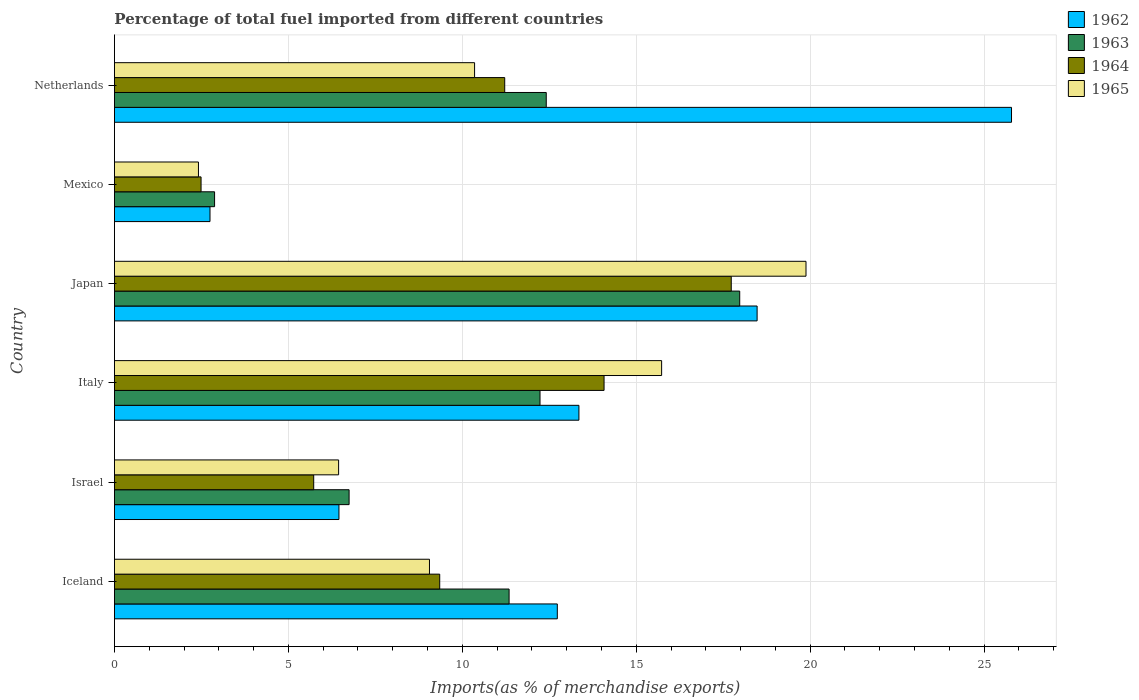How many different coloured bars are there?
Your answer should be very brief. 4. How many groups of bars are there?
Your response must be concise. 6. Are the number of bars per tick equal to the number of legend labels?
Provide a succinct answer. Yes. How many bars are there on the 1st tick from the top?
Offer a very short reply. 4. How many bars are there on the 6th tick from the bottom?
Ensure brevity in your answer.  4. What is the label of the 4th group of bars from the top?
Provide a succinct answer. Italy. In how many cases, is the number of bars for a given country not equal to the number of legend labels?
Provide a short and direct response. 0. What is the percentage of imports to different countries in 1964 in Japan?
Provide a short and direct response. 17.73. Across all countries, what is the maximum percentage of imports to different countries in 1964?
Make the answer very short. 17.73. Across all countries, what is the minimum percentage of imports to different countries in 1963?
Your answer should be compact. 2.88. In which country was the percentage of imports to different countries in 1964 minimum?
Give a very brief answer. Mexico. What is the total percentage of imports to different countries in 1965 in the graph?
Your response must be concise. 63.88. What is the difference between the percentage of imports to different countries in 1964 in Israel and that in Japan?
Offer a terse response. -12. What is the difference between the percentage of imports to different countries in 1962 in Japan and the percentage of imports to different countries in 1963 in Italy?
Provide a short and direct response. 6.24. What is the average percentage of imports to different countries in 1964 per country?
Make the answer very short. 10.1. What is the difference between the percentage of imports to different countries in 1963 and percentage of imports to different countries in 1965 in Iceland?
Offer a very short reply. 2.29. What is the ratio of the percentage of imports to different countries in 1965 in Israel to that in Italy?
Offer a very short reply. 0.41. Is the percentage of imports to different countries in 1962 in Italy less than that in Mexico?
Your response must be concise. No. What is the difference between the highest and the second highest percentage of imports to different countries in 1965?
Offer a very short reply. 4.15. What is the difference between the highest and the lowest percentage of imports to different countries in 1964?
Your answer should be compact. 15.24. Is it the case that in every country, the sum of the percentage of imports to different countries in 1962 and percentage of imports to different countries in 1963 is greater than the sum of percentage of imports to different countries in 1965 and percentage of imports to different countries in 1964?
Ensure brevity in your answer.  No. What does the 1st bar from the top in Mexico represents?
Your response must be concise. 1965. What does the 4th bar from the bottom in Iceland represents?
Offer a terse response. 1965. How many bars are there?
Provide a succinct answer. 24. Are all the bars in the graph horizontal?
Your response must be concise. Yes. What is the difference between two consecutive major ticks on the X-axis?
Provide a succinct answer. 5. How many legend labels are there?
Make the answer very short. 4. What is the title of the graph?
Keep it short and to the point. Percentage of total fuel imported from different countries. What is the label or title of the X-axis?
Offer a very short reply. Imports(as % of merchandise exports). What is the Imports(as % of merchandise exports) of 1962 in Iceland?
Provide a short and direct response. 12.73. What is the Imports(as % of merchandise exports) in 1963 in Iceland?
Provide a succinct answer. 11.35. What is the Imports(as % of merchandise exports) of 1964 in Iceland?
Make the answer very short. 9.35. What is the Imports(as % of merchandise exports) in 1965 in Iceland?
Ensure brevity in your answer.  9.06. What is the Imports(as % of merchandise exports) of 1962 in Israel?
Your answer should be compact. 6.45. What is the Imports(as % of merchandise exports) of 1963 in Israel?
Ensure brevity in your answer.  6.75. What is the Imports(as % of merchandise exports) in 1964 in Israel?
Offer a very short reply. 5.73. What is the Imports(as % of merchandise exports) in 1965 in Israel?
Ensure brevity in your answer.  6.44. What is the Imports(as % of merchandise exports) in 1962 in Italy?
Keep it short and to the point. 13.35. What is the Imports(as % of merchandise exports) of 1963 in Italy?
Provide a short and direct response. 12.23. What is the Imports(as % of merchandise exports) of 1964 in Italy?
Give a very brief answer. 14.07. What is the Imports(as % of merchandise exports) in 1965 in Italy?
Offer a very short reply. 15.73. What is the Imports(as % of merchandise exports) of 1962 in Japan?
Make the answer very short. 18.47. What is the Imports(as % of merchandise exports) of 1963 in Japan?
Give a very brief answer. 17.97. What is the Imports(as % of merchandise exports) of 1964 in Japan?
Your answer should be very brief. 17.73. What is the Imports(as % of merchandise exports) in 1965 in Japan?
Your response must be concise. 19.88. What is the Imports(as % of merchandise exports) of 1962 in Mexico?
Your answer should be very brief. 2.75. What is the Imports(as % of merchandise exports) of 1963 in Mexico?
Your answer should be very brief. 2.88. What is the Imports(as % of merchandise exports) in 1964 in Mexico?
Your response must be concise. 2.49. What is the Imports(as % of merchandise exports) of 1965 in Mexico?
Your answer should be compact. 2.42. What is the Imports(as % of merchandise exports) in 1962 in Netherlands?
Provide a succinct answer. 25.79. What is the Imports(as % of merchandise exports) of 1963 in Netherlands?
Provide a succinct answer. 12.41. What is the Imports(as % of merchandise exports) in 1964 in Netherlands?
Give a very brief answer. 11.22. What is the Imports(as % of merchandise exports) in 1965 in Netherlands?
Ensure brevity in your answer.  10.35. Across all countries, what is the maximum Imports(as % of merchandise exports) in 1962?
Keep it short and to the point. 25.79. Across all countries, what is the maximum Imports(as % of merchandise exports) of 1963?
Keep it short and to the point. 17.97. Across all countries, what is the maximum Imports(as % of merchandise exports) in 1964?
Your answer should be very brief. 17.73. Across all countries, what is the maximum Imports(as % of merchandise exports) in 1965?
Your answer should be compact. 19.88. Across all countries, what is the minimum Imports(as % of merchandise exports) of 1962?
Keep it short and to the point. 2.75. Across all countries, what is the minimum Imports(as % of merchandise exports) of 1963?
Your answer should be very brief. 2.88. Across all countries, what is the minimum Imports(as % of merchandise exports) of 1964?
Offer a terse response. 2.49. Across all countries, what is the minimum Imports(as % of merchandise exports) of 1965?
Offer a very short reply. 2.42. What is the total Imports(as % of merchandise exports) of 1962 in the graph?
Your answer should be very brief. 79.55. What is the total Imports(as % of merchandise exports) in 1963 in the graph?
Your response must be concise. 63.59. What is the total Imports(as % of merchandise exports) of 1964 in the graph?
Your answer should be very brief. 60.59. What is the total Imports(as % of merchandise exports) in 1965 in the graph?
Offer a terse response. 63.88. What is the difference between the Imports(as % of merchandise exports) in 1962 in Iceland and that in Israel?
Provide a short and direct response. 6.28. What is the difference between the Imports(as % of merchandise exports) in 1963 in Iceland and that in Israel?
Give a very brief answer. 4.6. What is the difference between the Imports(as % of merchandise exports) of 1964 in Iceland and that in Israel?
Keep it short and to the point. 3.62. What is the difference between the Imports(as % of merchandise exports) of 1965 in Iceland and that in Israel?
Your answer should be very brief. 2.61. What is the difference between the Imports(as % of merchandise exports) of 1962 in Iceland and that in Italy?
Ensure brevity in your answer.  -0.62. What is the difference between the Imports(as % of merchandise exports) in 1963 in Iceland and that in Italy?
Your answer should be very brief. -0.89. What is the difference between the Imports(as % of merchandise exports) in 1964 in Iceland and that in Italy?
Your response must be concise. -4.72. What is the difference between the Imports(as % of merchandise exports) in 1965 in Iceland and that in Italy?
Ensure brevity in your answer.  -6.67. What is the difference between the Imports(as % of merchandise exports) in 1962 in Iceland and that in Japan?
Your answer should be compact. -5.74. What is the difference between the Imports(as % of merchandise exports) in 1963 in Iceland and that in Japan?
Keep it short and to the point. -6.63. What is the difference between the Imports(as % of merchandise exports) in 1964 in Iceland and that in Japan?
Make the answer very short. -8.38. What is the difference between the Imports(as % of merchandise exports) of 1965 in Iceland and that in Japan?
Keep it short and to the point. -10.82. What is the difference between the Imports(as % of merchandise exports) of 1962 in Iceland and that in Mexico?
Give a very brief answer. 9.98. What is the difference between the Imports(as % of merchandise exports) in 1963 in Iceland and that in Mexico?
Offer a terse response. 8.47. What is the difference between the Imports(as % of merchandise exports) of 1964 in Iceland and that in Mexico?
Ensure brevity in your answer.  6.86. What is the difference between the Imports(as % of merchandise exports) of 1965 in Iceland and that in Mexico?
Your answer should be compact. 6.64. What is the difference between the Imports(as % of merchandise exports) of 1962 in Iceland and that in Netherlands?
Your answer should be compact. -13.06. What is the difference between the Imports(as % of merchandise exports) of 1963 in Iceland and that in Netherlands?
Offer a very short reply. -1.07. What is the difference between the Imports(as % of merchandise exports) of 1964 in Iceland and that in Netherlands?
Offer a very short reply. -1.87. What is the difference between the Imports(as % of merchandise exports) in 1965 in Iceland and that in Netherlands?
Your response must be concise. -1.3. What is the difference between the Imports(as % of merchandise exports) in 1962 in Israel and that in Italy?
Keep it short and to the point. -6.9. What is the difference between the Imports(as % of merchandise exports) in 1963 in Israel and that in Italy?
Your answer should be very brief. -5.49. What is the difference between the Imports(as % of merchandise exports) in 1964 in Israel and that in Italy?
Your answer should be compact. -8.35. What is the difference between the Imports(as % of merchandise exports) in 1965 in Israel and that in Italy?
Your answer should be very brief. -9.29. What is the difference between the Imports(as % of merchandise exports) in 1962 in Israel and that in Japan?
Keep it short and to the point. -12.02. What is the difference between the Imports(as % of merchandise exports) of 1963 in Israel and that in Japan?
Provide a short and direct response. -11.23. What is the difference between the Imports(as % of merchandise exports) of 1964 in Israel and that in Japan?
Ensure brevity in your answer.  -12. What is the difference between the Imports(as % of merchandise exports) of 1965 in Israel and that in Japan?
Provide a short and direct response. -13.44. What is the difference between the Imports(as % of merchandise exports) in 1962 in Israel and that in Mexico?
Give a very brief answer. 3.71. What is the difference between the Imports(as % of merchandise exports) of 1963 in Israel and that in Mexico?
Provide a short and direct response. 3.87. What is the difference between the Imports(as % of merchandise exports) of 1964 in Israel and that in Mexico?
Your answer should be compact. 3.24. What is the difference between the Imports(as % of merchandise exports) in 1965 in Israel and that in Mexico?
Your answer should be compact. 4.03. What is the difference between the Imports(as % of merchandise exports) of 1962 in Israel and that in Netherlands?
Make the answer very short. -19.33. What is the difference between the Imports(as % of merchandise exports) of 1963 in Israel and that in Netherlands?
Your answer should be very brief. -5.67. What is the difference between the Imports(as % of merchandise exports) of 1964 in Israel and that in Netherlands?
Your response must be concise. -5.49. What is the difference between the Imports(as % of merchandise exports) of 1965 in Israel and that in Netherlands?
Provide a succinct answer. -3.91. What is the difference between the Imports(as % of merchandise exports) of 1962 in Italy and that in Japan?
Give a very brief answer. -5.12. What is the difference between the Imports(as % of merchandise exports) of 1963 in Italy and that in Japan?
Keep it short and to the point. -5.74. What is the difference between the Imports(as % of merchandise exports) of 1964 in Italy and that in Japan?
Provide a succinct answer. -3.66. What is the difference between the Imports(as % of merchandise exports) of 1965 in Italy and that in Japan?
Provide a short and direct response. -4.15. What is the difference between the Imports(as % of merchandise exports) of 1962 in Italy and that in Mexico?
Your answer should be compact. 10.61. What is the difference between the Imports(as % of merchandise exports) of 1963 in Italy and that in Mexico?
Your answer should be compact. 9.36. What is the difference between the Imports(as % of merchandise exports) of 1964 in Italy and that in Mexico?
Make the answer very short. 11.58. What is the difference between the Imports(as % of merchandise exports) in 1965 in Italy and that in Mexico?
Make the answer very short. 13.31. What is the difference between the Imports(as % of merchandise exports) of 1962 in Italy and that in Netherlands?
Provide a succinct answer. -12.44. What is the difference between the Imports(as % of merchandise exports) of 1963 in Italy and that in Netherlands?
Keep it short and to the point. -0.18. What is the difference between the Imports(as % of merchandise exports) in 1964 in Italy and that in Netherlands?
Your response must be concise. 2.86. What is the difference between the Imports(as % of merchandise exports) of 1965 in Italy and that in Netherlands?
Your answer should be compact. 5.38. What is the difference between the Imports(as % of merchandise exports) in 1962 in Japan and that in Mexico?
Offer a terse response. 15.73. What is the difference between the Imports(as % of merchandise exports) in 1963 in Japan and that in Mexico?
Your response must be concise. 15.1. What is the difference between the Imports(as % of merchandise exports) in 1964 in Japan and that in Mexico?
Offer a very short reply. 15.24. What is the difference between the Imports(as % of merchandise exports) of 1965 in Japan and that in Mexico?
Provide a short and direct response. 17.46. What is the difference between the Imports(as % of merchandise exports) of 1962 in Japan and that in Netherlands?
Offer a very short reply. -7.31. What is the difference between the Imports(as % of merchandise exports) of 1963 in Japan and that in Netherlands?
Your response must be concise. 5.56. What is the difference between the Imports(as % of merchandise exports) in 1964 in Japan and that in Netherlands?
Your answer should be compact. 6.51. What is the difference between the Imports(as % of merchandise exports) in 1965 in Japan and that in Netherlands?
Offer a terse response. 9.53. What is the difference between the Imports(as % of merchandise exports) of 1962 in Mexico and that in Netherlands?
Your answer should be compact. -23.04. What is the difference between the Imports(as % of merchandise exports) in 1963 in Mexico and that in Netherlands?
Your answer should be very brief. -9.53. What is the difference between the Imports(as % of merchandise exports) in 1964 in Mexico and that in Netherlands?
Provide a short and direct response. -8.73. What is the difference between the Imports(as % of merchandise exports) of 1965 in Mexico and that in Netherlands?
Give a very brief answer. -7.94. What is the difference between the Imports(as % of merchandise exports) of 1962 in Iceland and the Imports(as % of merchandise exports) of 1963 in Israel?
Ensure brevity in your answer.  5.99. What is the difference between the Imports(as % of merchandise exports) in 1962 in Iceland and the Imports(as % of merchandise exports) in 1964 in Israel?
Make the answer very short. 7. What is the difference between the Imports(as % of merchandise exports) of 1962 in Iceland and the Imports(as % of merchandise exports) of 1965 in Israel?
Your response must be concise. 6.29. What is the difference between the Imports(as % of merchandise exports) in 1963 in Iceland and the Imports(as % of merchandise exports) in 1964 in Israel?
Give a very brief answer. 5.62. What is the difference between the Imports(as % of merchandise exports) of 1963 in Iceland and the Imports(as % of merchandise exports) of 1965 in Israel?
Your response must be concise. 4.9. What is the difference between the Imports(as % of merchandise exports) in 1964 in Iceland and the Imports(as % of merchandise exports) in 1965 in Israel?
Your answer should be very brief. 2.91. What is the difference between the Imports(as % of merchandise exports) of 1962 in Iceland and the Imports(as % of merchandise exports) of 1963 in Italy?
Provide a short and direct response. 0.5. What is the difference between the Imports(as % of merchandise exports) of 1962 in Iceland and the Imports(as % of merchandise exports) of 1964 in Italy?
Make the answer very short. -1.34. What is the difference between the Imports(as % of merchandise exports) in 1962 in Iceland and the Imports(as % of merchandise exports) in 1965 in Italy?
Make the answer very short. -3. What is the difference between the Imports(as % of merchandise exports) in 1963 in Iceland and the Imports(as % of merchandise exports) in 1964 in Italy?
Give a very brief answer. -2.73. What is the difference between the Imports(as % of merchandise exports) in 1963 in Iceland and the Imports(as % of merchandise exports) in 1965 in Italy?
Keep it short and to the point. -4.38. What is the difference between the Imports(as % of merchandise exports) of 1964 in Iceland and the Imports(as % of merchandise exports) of 1965 in Italy?
Make the answer very short. -6.38. What is the difference between the Imports(as % of merchandise exports) of 1962 in Iceland and the Imports(as % of merchandise exports) of 1963 in Japan?
Ensure brevity in your answer.  -5.24. What is the difference between the Imports(as % of merchandise exports) of 1962 in Iceland and the Imports(as % of merchandise exports) of 1964 in Japan?
Provide a succinct answer. -5. What is the difference between the Imports(as % of merchandise exports) in 1962 in Iceland and the Imports(as % of merchandise exports) in 1965 in Japan?
Your answer should be very brief. -7.15. What is the difference between the Imports(as % of merchandise exports) of 1963 in Iceland and the Imports(as % of merchandise exports) of 1964 in Japan?
Your response must be concise. -6.39. What is the difference between the Imports(as % of merchandise exports) of 1963 in Iceland and the Imports(as % of merchandise exports) of 1965 in Japan?
Offer a terse response. -8.53. What is the difference between the Imports(as % of merchandise exports) in 1964 in Iceland and the Imports(as % of merchandise exports) in 1965 in Japan?
Your answer should be very brief. -10.53. What is the difference between the Imports(as % of merchandise exports) in 1962 in Iceland and the Imports(as % of merchandise exports) in 1963 in Mexico?
Provide a short and direct response. 9.85. What is the difference between the Imports(as % of merchandise exports) in 1962 in Iceland and the Imports(as % of merchandise exports) in 1964 in Mexico?
Make the answer very short. 10.24. What is the difference between the Imports(as % of merchandise exports) of 1962 in Iceland and the Imports(as % of merchandise exports) of 1965 in Mexico?
Offer a very short reply. 10.32. What is the difference between the Imports(as % of merchandise exports) of 1963 in Iceland and the Imports(as % of merchandise exports) of 1964 in Mexico?
Keep it short and to the point. 8.85. What is the difference between the Imports(as % of merchandise exports) in 1963 in Iceland and the Imports(as % of merchandise exports) in 1965 in Mexico?
Offer a terse response. 8.93. What is the difference between the Imports(as % of merchandise exports) of 1964 in Iceland and the Imports(as % of merchandise exports) of 1965 in Mexico?
Your answer should be very brief. 6.94. What is the difference between the Imports(as % of merchandise exports) of 1962 in Iceland and the Imports(as % of merchandise exports) of 1963 in Netherlands?
Keep it short and to the point. 0.32. What is the difference between the Imports(as % of merchandise exports) in 1962 in Iceland and the Imports(as % of merchandise exports) in 1964 in Netherlands?
Provide a short and direct response. 1.51. What is the difference between the Imports(as % of merchandise exports) of 1962 in Iceland and the Imports(as % of merchandise exports) of 1965 in Netherlands?
Ensure brevity in your answer.  2.38. What is the difference between the Imports(as % of merchandise exports) in 1963 in Iceland and the Imports(as % of merchandise exports) in 1964 in Netherlands?
Your answer should be compact. 0.13. What is the difference between the Imports(as % of merchandise exports) in 1963 in Iceland and the Imports(as % of merchandise exports) in 1965 in Netherlands?
Your response must be concise. 0.99. What is the difference between the Imports(as % of merchandise exports) of 1964 in Iceland and the Imports(as % of merchandise exports) of 1965 in Netherlands?
Make the answer very short. -1. What is the difference between the Imports(as % of merchandise exports) of 1962 in Israel and the Imports(as % of merchandise exports) of 1963 in Italy?
Provide a succinct answer. -5.78. What is the difference between the Imports(as % of merchandise exports) in 1962 in Israel and the Imports(as % of merchandise exports) in 1964 in Italy?
Make the answer very short. -7.62. What is the difference between the Imports(as % of merchandise exports) in 1962 in Israel and the Imports(as % of merchandise exports) in 1965 in Italy?
Keep it short and to the point. -9.28. What is the difference between the Imports(as % of merchandise exports) of 1963 in Israel and the Imports(as % of merchandise exports) of 1964 in Italy?
Provide a succinct answer. -7.33. What is the difference between the Imports(as % of merchandise exports) in 1963 in Israel and the Imports(as % of merchandise exports) in 1965 in Italy?
Your response must be concise. -8.98. What is the difference between the Imports(as % of merchandise exports) of 1964 in Israel and the Imports(as % of merchandise exports) of 1965 in Italy?
Provide a succinct answer. -10. What is the difference between the Imports(as % of merchandise exports) in 1962 in Israel and the Imports(as % of merchandise exports) in 1963 in Japan?
Keep it short and to the point. -11.52. What is the difference between the Imports(as % of merchandise exports) of 1962 in Israel and the Imports(as % of merchandise exports) of 1964 in Japan?
Your answer should be very brief. -11.28. What is the difference between the Imports(as % of merchandise exports) of 1962 in Israel and the Imports(as % of merchandise exports) of 1965 in Japan?
Provide a short and direct response. -13.43. What is the difference between the Imports(as % of merchandise exports) in 1963 in Israel and the Imports(as % of merchandise exports) in 1964 in Japan?
Your response must be concise. -10.99. What is the difference between the Imports(as % of merchandise exports) in 1963 in Israel and the Imports(as % of merchandise exports) in 1965 in Japan?
Make the answer very short. -13.13. What is the difference between the Imports(as % of merchandise exports) in 1964 in Israel and the Imports(as % of merchandise exports) in 1965 in Japan?
Keep it short and to the point. -14.15. What is the difference between the Imports(as % of merchandise exports) in 1962 in Israel and the Imports(as % of merchandise exports) in 1963 in Mexico?
Make the answer very short. 3.58. What is the difference between the Imports(as % of merchandise exports) in 1962 in Israel and the Imports(as % of merchandise exports) in 1964 in Mexico?
Keep it short and to the point. 3.96. What is the difference between the Imports(as % of merchandise exports) of 1962 in Israel and the Imports(as % of merchandise exports) of 1965 in Mexico?
Your response must be concise. 4.04. What is the difference between the Imports(as % of merchandise exports) in 1963 in Israel and the Imports(as % of merchandise exports) in 1964 in Mexico?
Your response must be concise. 4.26. What is the difference between the Imports(as % of merchandise exports) in 1963 in Israel and the Imports(as % of merchandise exports) in 1965 in Mexico?
Provide a succinct answer. 4.33. What is the difference between the Imports(as % of merchandise exports) of 1964 in Israel and the Imports(as % of merchandise exports) of 1965 in Mexico?
Keep it short and to the point. 3.31. What is the difference between the Imports(as % of merchandise exports) in 1962 in Israel and the Imports(as % of merchandise exports) in 1963 in Netherlands?
Keep it short and to the point. -5.96. What is the difference between the Imports(as % of merchandise exports) in 1962 in Israel and the Imports(as % of merchandise exports) in 1964 in Netherlands?
Give a very brief answer. -4.76. What is the difference between the Imports(as % of merchandise exports) of 1962 in Israel and the Imports(as % of merchandise exports) of 1965 in Netherlands?
Provide a succinct answer. -3.9. What is the difference between the Imports(as % of merchandise exports) in 1963 in Israel and the Imports(as % of merchandise exports) in 1964 in Netherlands?
Your response must be concise. -4.47. What is the difference between the Imports(as % of merchandise exports) in 1963 in Israel and the Imports(as % of merchandise exports) in 1965 in Netherlands?
Your response must be concise. -3.61. What is the difference between the Imports(as % of merchandise exports) of 1964 in Israel and the Imports(as % of merchandise exports) of 1965 in Netherlands?
Provide a short and direct response. -4.62. What is the difference between the Imports(as % of merchandise exports) in 1962 in Italy and the Imports(as % of merchandise exports) in 1963 in Japan?
Ensure brevity in your answer.  -4.62. What is the difference between the Imports(as % of merchandise exports) of 1962 in Italy and the Imports(as % of merchandise exports) of 1964 in Japan?
Ensure brevity in your answer.  -4.38. What is the difference between the Imports(as % of merchandise exports) in 1962 in Italy and the Imports(as % of merchandise exports) in 1965 in Japan?
Make the answer very short. -6.53. What is the difference between the Imports(as % of merchandise exports) in 1963 in Italy and the Imports(as % of merchandise exports) in 1964 in Japan?
Offer a very short reply. -5.5. What is the difference between the Imports(as % of merchandise exports) in 1963 in Italy and the Imports(as % of merchandise exports) in 1965 in Japan?
Give a very brief answer. -7.65. What is the difference between the Imports(as % of merchandise exports) in 1964 in Italy and the Imports(as % of merchandise exports) in 1965 in Japan?
Give a very brief answer. -5.8. What is the difference between the Imports(as % of merchandise exports) in 1962 in Italy and the Imports(as % of merchandise exports) in 1963 in Mexico?
Offer a terse response. 10.47. What is the difference between the Imports(as % of merchandise exports) in 1962 in Italy and the Imports(as % of merchandise exports) in 1964 in Mexico?
Ensure brevity in your answer.  10.86. What is the difference between the Imports(as % of merchandise exports) of 1962 in Italy and the Imports(as % of merchandise exports) of 1965 in Mexico?
Provide a short and direct response. 10.94. What is the difference between the Imports(as % of merchandise exports) in 1963 in Italy and the Imports(as % of merchandise exports) in 1964 in Mexico?
Your answer should be compact. 9.74. What is the difference between the Imports(as % of merchandise exports) of 1963 in Italy and the Imports(as % of merchandise exports) of 1965 in Mexico?
Your response must be concise. 9.82. What is the difference between the Imports(as % of merchandise exports) in 1964 in Italy and the Imports(as % of merchandise exports) in 1965 in Mexico?
Provide a succinct answer. 11.66. What is the difference between the Imports(as % of merchandise exports) of 1962 in Italy and the Imports(as % of merchandise exports) of 1963 in Netherlands?
Provide a short and direct response. 0.94. What is the difference between the Imports(as % of merchandise exports) of 1962 in Italy and the Imports(as % of merchandise exports) of 1964 in Netherlands?
Ensure brevity in your answer.  2.13. What is the difference between the Imports(as % of merchandise exports) of 1962 in Italy and the Imports(as % of merchandise exports) of 1965 in Netherlands?
Give a very brief answer. 3. What is the difference between the Imports(as % of merchandise exports) in 1963 in Italy and the Imports(as % of merchandise exports) in 1964 in Netherlands?
Offer a very short reply. 1.01. What is the difference between the Imports(as % of merchandise exports) of 1963 in Italy and the Imports(as % of merchandise exports) of 1965 in Netherlands?
Provide a short and direct response. 1.88. What is the difference between the Imports(as % of merchandise exports) in 1964 in Italy and the Imports(as % of merchandise exports) in 1965 in Netherlands?
Ensure brevity in your answer.  3.72. What is the difference between the Imports(as % of merchandise exports) of 1962 in Japan and the Imports(as % of merchandise exports) of 1963 in Mexico?
Offer a very short reply. 15.6. What is the difference between the Imports(as % of merchandise exports) in 1962 in Japan and the Imports(as % of merchandise exports) in 1964 in Mexico?
Your response must be concise. 15.98. What is the difference between the Imports(as % of merchandise exports) of 1962 in Japan and the Imports(as % of merchandise exports) of 1965 in Mexico?
Provide a succinct answer. 16.06. What is the difference between the Imports(as % of merchandise exports) in 1963 in Japan and the Imports(as % of merchandise exports) in 1964 in Mexico?
Ensure brevity in your answer.  15.48. What is the difference between the Imports(as % of merchandise exports) of 1963 in Japan and the Imports(as % of merchandise exports) of 1965 in Mexico?
Offer a terse response. 15.56. What is the difference between the Imports(as % of merchandise exports) in 1964 in Japan and the Imports(as % of merchandise exports) in 1965 in Mexico?
Make the answer very short. 15.32. What is the difference between the Imports(as % of merchandise exports) of 1962 in Japan and the Imports(as % of merchandise exports) of 1963 in Netherlands?
Offer a very short reply. 6.06. What is the difference between the Imports(as % of merchandise exports) of 1962 in Japan and the Imports(as % of merchandise exports) of 1964 in Netherlands?
Your response must be concise. 7.25. What is the difference between the Imports(as % of merchandise exports) of 1962 in Japan and the Imports(as % of merchandise exports) of 1965 in Netherlands?
Provide a succinct answer. 8.12. What is the difference between the Imports(as % of merchandise exports) of 1963 in Japan and the Imports(as % of merchandise exports) of 1964 in Netherlands?
Your answer should be compact. 6.76. What is the difference between the Imports(as % of merchandise exports) in 1963 in Japan and the Imports(as % of merchandise exports) in 1965 in Netherlands?
Give a very brief answer. 7.62. What is the difference between the Imports(as % of merchandise exports) in 1964 in Japan and the Imports(as % of merchandise exports) in 1965 in Netherlands?
Ensure brevity in your answer.  7.38. What is the difference between the Imports(as % of merchandise exports) in 1962 in Mexico and the Imports(as % of merchandise exports) in 1963 in Netherlands?
Offer a terse response. -9.67. What is the difference between the Imports(as % of merchandise exports) in 1962 in Mexico and the Imports(as % of merchandise exports) in 1964 in Netherlands?
Make the answer very short. -8.47. What is the difference between the Imports(as % of merchandise exports) of 1962 in Mexico and the Imports(as % of merchandise exports) of 1965 in Netherlands?
Your answer should be very brief. -7.61. What is the difference between the Imports(as % of merchandise exports) in 1963 in Mexico and the Imports(as % of merchandise exports) in 1964 in Netherlands?
Provide a short and direct response. -8.34. What is the difference between the Imports(as % of merchandise exports) of 1963 in Mexico and the Imports(as % of merchandise exports) of 1965 in Netherlands?
Offer a terse response. -7.47. What is the difference between the Imports(as % of merchandise exports) of 1964 in Mexico and the Imports(as % of merchandise exports) of 1965 in Netherlands?
Your answer should be compact. -7.86. What is the average Imports(as % of merchandise exports) of 1962 per country?
Offer a very short reply. 13.26. What is the average Imports(as % of merchandise exports) in 1963 per country?
Give a very brief answer. 10.6. What is the average Imports(as % of merchandise exports) in 1964 per country?
Offer a terse response. 10.1. What is the average Imports(as % of merchandise exports) in 1965 per country?
Your response must be concise. 10.65. What is the difference between the Imports(as % of merchandise exports) in 1962 and Imports(as % of merchandise exports) in 1963 in Iceland?
Provide a short and direct response. 1.39. What is the difference between the Imports(as % of merchandise exports) of 1962 and Imports(as % of merchandise exports) of 1964 in Iceland?
Provide a short and direct response. 3.38. What is the difference between the Imports(as % of merchandise exports) in 1962 and Imports(as % of merchandise exports) in 1965 in Iceland?
Make the answer very short. 3.67. What is the difference between the Imports(as % of merchandise exports) of 1963 and Imports(as % of merchandise exports) of 1964 in Iceland?
Provide a short and direct response. 1.99. What is the difference between the Imports(as % of merchandise exports) in 1963 and Imports(as % of merchandise exports) in 1965 in Iceland?
Offer a very short reply. 2.29. What is the difference between the Imports(as % of merchandise exports) of 1964 and Imports(as % of merchandise exports) of 1965 in Iceland?
Your answer should be compact. 0.29. What is the difference between the Imports(as % of merchandise exports) in 1962 and Imports(as % of merchandise exports) in 1963 in Israel?
Offer a terse response. -0.29. What is the difference between the Imports(as % of merchandise exports) in 1962 and Imports(as % of merchandise exports) in 1964 in Israel?
Provide a succinct answer. 0.73. What is the difference between the Imports(as % of merchandise exports) of 1962 and Imports(as % of merchandise exports) of 1965 in Israel?
Make the answer very short. 0.01. What is the difference between the Imports(as % of merchandise exports) of 1963 and Imports(as % of merchandise exports) of 1964 in Israel?
Keep it short and to the point. 1.02. What is the difference between the Imports(as % of merchandise exports) of 1963 and Imports(as % of merchandise exports) of 1965 in Israel?
Offer a terse response. 0.3. What is the difference between the Imports(as % of merchandise exports) in 1964 and Imports(as % of merchandise exports) in 1965 in Israel?
Keep it short and to the point. -0.72. What is the difference between the Imports(as % of merchandise exports) in 1962 and Imports(as % of merchandise exports) in 1963 in Italy?
Your answer should be compact. 1.12. What is the difference between the Imports(as % of merchandise exports) in 1962 and Imports(as % of merchandise exports) in 1964 in Italy?
Your response must be concise. -0.72. What is the difference between the Imports(as % of merchandise exports) of 1962 and Imports(as % of merchandise exports) of 1965 in Italy?
Make the answer very short. -2.38. What is the difference between the Imports(as % of merchandise exports) in 1963 and Imports(as % of merchandise exports) in 1964 in Italy?
Your answer should be compact. -1.84. What is the difference between the Imports(as % of merchandise exports) in 1963 and Imports(as % of merchandise exports) in 1965 in Italy?
Your response must be concise. -3.5. What is the difference between the Imports(as % of merchandise exports) of 1964 and Imports(as % of merchandise exports) of 1965 in Italy?
Provide a short and direct response. -1.65. What is the difference between the Imports(as % of merchandise exports) in 1962 and Imports(as % of merchandise exports) in 1964 in Japan?
Provide a short and direct response. 0.74. What is the difference between the Imports(as % of merchandise exports) in 1962 and Imports(as % of merchandise exports) in 1965 in Japan?
Keep it short and to the point. -1.41. What is the difference between the Imports(as % of merchandise exports) of 1963 and Imports(as % of merchandise exports) of 1964 in Japan?
Make the answer very short. 0.24. What is the difference between the Imports(as % of merchandise exports) in 1963 and Imports(as % of merchandise exports) in 1965 in Japan?
Ensure brevity in your answer.  -1.91. What is the difference between the Imports(as % of merchandise exports) of 1964 and Imports(as % of merchandise exports) of 1965 in Japan?
Provide a short and direct response. -2.15. What is the difference between the Imports(as % of merchandise exports) of 1962 and Imports(as % of merchandise exports) of 1963 in Mexico?
Your answer should be very brief. -0.13. What is the difference between the Imports(as % of merchandise exports) in 1962 and Imports(as % of merchandise exports) in 1964 in Mexico?
Make the answer very short. 0.26. What is the difference between the Imports(as % of merchandise exports) of 1962 and Imports(as % of merchandise exports) of 1965 in Mexico?
Provide a succinct answer. 0.33. What is the difference between the Imports(as % of merchandise exports) in 1963 and Imports(as % of merchandise exports) in 1964 in Mexico?
Offer a terse response. 0.39. What is the difference between the Imports(as % of merchandise exports) of 1963 and Imports(as % of merchandise exports) of 1965 in Mexico?
Your response must be concise. 0.46. What is the difference between the Imports(as % of merchandise exports) in 1964 and Imports(as % of merchandise exports) in 1965 in Mexico?
Provide a short and direct response. 0.07. What is the difference between the Imports(as % of merchandise exports) of 1962 and Imports(as % of merchandise exports) of 1963 in Netherlands?
Your answer should be very brief. 13.37. What is the difference between the Imports(as % of merchandise exports) in 1962 and Imports(as % of merchandise exports) in 1964 in Netherlands?
Ensure brevity in your answer.  14.57. What is the difference between the Imports(as % of merchandise exports) in 1962 and Imports(as % of merchandise exports) in 1965 in Netherlands?
Your answer should be compact. 15.43. What is the difference between the Imports(as % of merchandise exports) of 1963 and Imports(as % of merchandise exports) of 1964 in Netherlands?
Your response must be concise. 1.19. What is the difference between the Imports(as % of merchandise exports) in 1963 and Imports(as % of merchandise exports) in 1965 in Netherlands?
Offer a terse response. 2.06. What is the difference between the Imports(as % of merchandise exports) in 1964 and Imports(as % of merchandise exports) in 1965 in Netherlands?
Your answer should be compact. 0.87. What is the ratio of the Imports(as % of merchandise exports) of 1962 in Iceland to that in Israel?
Keep it short and to the point. 1.97. What is the ratio of the Imports(as % of merchandise exports) of 1963 in Iceland to that in Israel?
Offer a terse response. 1.68. What is the ratio of the Imports(as % of merchandise exports) of 1964 in Iceland to that in Israel?
Offer a very short reply. 1.63. What is the ratio of the Imports(as % of merchandise exports) of 1965 in Iceland to that in Israel?
Provide a short and direct response. 1.41. What is the ratio of the Imports(as % of merchandise exports) in 1962 in Iceland to that in Italy?
Offer a terse response. 0.95. What is the ratio of the Imports(as % of merchandise exports) of 1963 in Iceland to that in Italy?
Your response must be concise. 0.93. What is the ratio of the Imports(as % of merchandise exports) in 1964 in Iceland to that in Italy?
Offer a very short reply. 0.66. What is the ratio of the Imports(as % of merchandise exports) of 1965 in Iceland to that in Italy?
Ensure brevity in your answer.  0.58. What is the ratio of the Imports(as % of merchandise exports) in 1962 in Iceland to that in Japan?
Your answer should be very brief. 0.69. What is the ratio of the Imports(as % of merchandise exports) of 1963 in Iceland to that in Japan?
Make the answer very short. 0.63. What is the ratio of the Imports(as % of merchandise exports) in 1964 in Iceland to that in Japan?
Provide a succinct answer. 0.53. What is the ratio of the Imports(as % of merchandise exports) in 1965 in Iceland to that in Japan?
Your answer should be compact. 0.46. What is the ratio of the Imports(as % of merchandise exports) of 1962 in Iceland to that in Mexico?
Make the answer very short. 4.63. What is the ratio of the Imports(as % of merchandise exports) of 1963 in Iceland to that in Mexico?
Your answer should be very brief. 3.94. What is the ratio of the Imports(as % of merchandise exports) of 1964 in Iceland to that in Mexico?
Give a very brief answer. 3.76. What is the ratio of the Imports(as % of merchandise exports) of 1965 in Iceland to that in Mexico?
Offer a very short reply. 3.75. What is the ratio of the Imports(as % of merchandise exports) of 1962 in Iceland to that in Netherlands?
Make the answer very short. 0.49. What is the ratio of the Imports(as % of merchandise exports) of 1963 in Iceland to that in Netherlands?
Offer a terse response. 0.91. What is the ratio of the Imports(as % of merchandise exports) of 1964 in Iceland to that in Netherlands?
Offer a terse response. 0.83. What is the ratio of the Imports(as % of merchandise exports) in 1965 in Iceland to that in Netherlands?
Keep it short and to the point. 0.87. What is the ratio of the Imports(as % of merchandise exports) in 1962 in Israel to that in Italy?
Your response must be concise. 0.48. What is the ratio of the Imports(as % of merchandise exports) in 1963 in Israel to that in Italy?
Provide a short and direct response. 0.55. What is the ratio of the Imports(as % of merchandise exports) in 1964 in Israel to that in Italy?
Provide a short and direct response. 0.41. What is the ratio of the Imports(as % of merchandise exports) of 1965 in Israel to that in Italy?
Offer a very short reply. 0.41. What is the ratio of the Imports(as % of merchandise exports) of 1962 in Israel to that in Japan?
Keep it short and to the point. 0.35. What is the ratio of the Imports(as % of merchandise exports) in 1963 in Israel to that in Japan?
Offer a terse response. 0.38. What is the ratio of the Imports(as % of merchandise exports) of 1964 in Israel to that in Japan?
Your answer should be compact. 0.32. What is the ratio of the Imports(as % of merchandise exports) in 1965 in Israel to that in Japan?
Your response must be concise. 0.32. What is the ratio of the Imports(as % of merchandise exports) of 1962 in Israel to that in Mexico?
Keep it short and to the point. 2.35. What is the ratio of the Imports(as % of merchandise exports) of 1963 in Israel to that in Mexico?
Make the answer very short. 2.34. What is the ratio of the Imports(as % of merchandise exports) in 1964 in Israel to that in Mexico?
Provide a short and direct response. 2.3. What is the ratio of the Imports(as % of merchandise exports) of 1965 in Israel to that in Mexico?
Keep it short and to the point. 2.67. What is the ratio of the Imports(as % of merchandise exports) of 1962 in Israel to that in Netherlands?
Your answer should be compact. 0.25. What is the ratio of the Imports(as % of merchandise exports) of 1963 in Israel to that in Netherlands?
Provide a short and direct response. 0.54. What is the ratio of the Imports(as % of merchandise exports) of 1964 in Israel to that in Netherlands?
Provide a succinct answer. 0.51. What is the ratio of the Imports(as % of merchandise exports) of 1965 in Israel to that in Netherlands?
Your answer should be compact. 0.62. What is the ratio of the Imports(as % of merchandise exports) of 1962 in Italy to that in Japan?
Offer a very short reply. 0.72. What is the ratio of the Imports(as % of merchandise exports) in 1963 in Italy to that in Japan?
Provide a short and direct response. 0.68. What is the ratio of the Imports(as % of merchandise exports) of 1964 in Italy to that in Japan?
Your response must be concise. 0.79. What is the ratio of the Imports(as % of merchandise exports) of 1965 in Italy to that in Japan?
Ensure brevity in your answer.  0.79. What is the ratio of the Imports(as % of merchandise exports) in 1962 in Italy to that in Mexico?
Your answer should be compact. 4.86. What is the ratio of the Imports(as % of merchandise exports) in 1963 in Italy to that in Mexico?
Give a very brief answer. 4.25. What is the ratio of the Imports(as % of merchandise exports) in 1964 in Italy to that in Mexico?
Offer a very short reply. 5.65. What is the ratio of the Imports(as % of merchandise exports) in 1965 in Italy to that in Mexico?
Your answer should be very brief. 6.51. What is the ratio of the Imports(as % of merchandise exports) of 1962 in Italy to that in Netherlands?
Your answer should be very brief. 0.52. What is the ratio of the Imports(as % of merchandise exports) of 1963 in Italy to that in Netherlands?
Your answer should be very brief. 0.99. What is the ratio of the Imports(as % of merchandise exports) of 1964 in Italy to that in Netherlands?
Your answer should be compact. 1.25. What is the ratio of the Imports(as % of merchandise exports) of 1965 in Italy to that in Netherlands?
Give a very brief answer. 1.52. What is the ratio of the Imports(as % of merchandise exports) in 1962 in Japan to that in Mexico?
Offer a very short reply. 6.72. What is the ratio of the Imports(as % of merchandise exports) of 1963 in Japan to that in Mexico?
Provide a succinct answer. 6.24. What is the ratio of the Imports(as % of merchandise exports) in 1964 in Japan to that in Mexico?
Make the answer very short. 7.12. What is the ratio of the Imports(as % of merchandise exports) in 1965 in Japan to that in Mexico?
Provide a short and direct response. 8.23. What is the ratio of the Imports(as % of merchandise exports) of 1962 in Japan to that in Netherlands?
Provide a short and direct response. 0.72. What is the ratio of the Imports(as % of merchandise exports) of 1963 in Japan to that in Netherlands?
Give a very brief answer. 1.45. What is the ratio of the Imports(as % of merchandise exports) of 1964 in Japan to that in Netherlands?
Provide a short and direct response. 1.58. What is the ratio of the Imports(as % of merchandise exports) in 1965 in Japan to that in Netherlands?
Make the answer very short. 1.92. What is the ratio of the Imports(as % of merchandise exports) of 1962 in Mexico to that in Netherlands?
Offer a very short reply. 0.11. What is the ratio of the Imports(as % of merchandise exports) of 1963 in Mexico to that in Netherlands?
Your response must be concise. 0.23. What is the ratio of the Imports(as % of merchandise exports) of 1964 in Mexico to that in Netherlands?
Your answer should be very brief. 0.22. What is the ratio of the Imports(as % of merchandise exports) in 1965 in Mexico to that in Netherlands?
Provide a succinct answer. 0.23. What is the difference between the highest and the second highest Imports(as % of merchandise exports) of 1962?
Provide a short and direct response. 7.31. What is the difference between the highest and the second highest Imports(as % of merchandise exports) in 1963?
Ensure brevity in your answer.  5.56. What is the difference between the highest and the second highest Imports(as % of merchandise exports) in 1964?
Keep it short and to the point. 3.66. What is the difference between the highest and the second highest Imports(as % of merchandise exports) in 1965?
Give a very brief answer. 4.15. What is the difference between the highest and the lowest Imports(as % of merchandise exports) of 1962?
Your response must be concise. 23.04. What is the difference between the highest and the lowest Imports(as % of merchandise exports) of 1963?
Your answer should be very brief. 15.1. What is the difference between the highest and the lowest Imports(as % of merchandise exports) of 1964?
Provide a short and direct response. 15.24. What is the difference between the highest and the lowest Imports(as % of merchandise exports) in 1965?
Give a very brief answer. 17.46. 